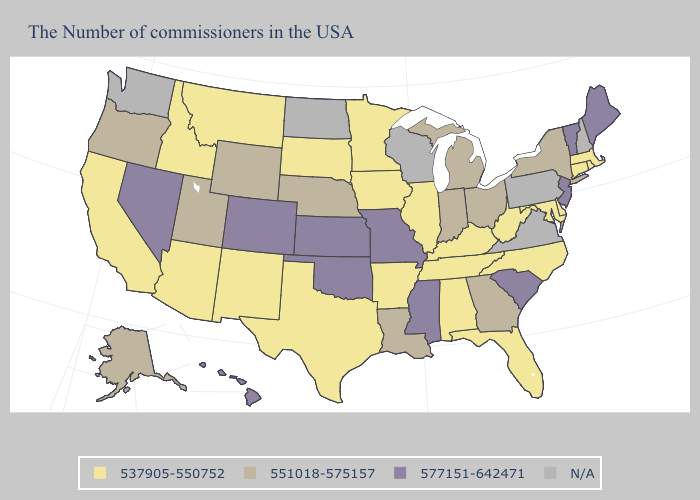What is the value of Arizona?
Concise answer only. 537905-550752. Name the states that have a value in the range 551018-575157?
Concise answer only. New York, Ohio, Georgia, Michigan, Indiana, Louisiana, Nebraska, Wyoming, Utah, Oregon, Alaska. Which states hav the highest value in the Northeast?
Answer briefly. Maine, Vermont, New Jersey. Name the states that have a value in the range 551018-575157?
Answer briefly. New York, Ohio, Georgia, Michigan, Indiana, Louisiana, Nebraska, Wyoming, Utah, Oregon, Alaska. Among the states that border Tennessee , does Arkansas have the lowest value?
Give a very brief answer. Yes. Does Georgia have the highest value in the South?
Give a very brief answer. No. What is the highest value in states that border North Dakota?
Write a very short answer. 537905-550752. Name the states that have a value in the range 577151-642471?
Short answer required. Maine, Vermont, New Jersey, South Carolina, Mississippi, Missouri, Kansas, Oklahoma, Colorado, Nevada, Hawaii. What is the value of Michigan?
Be succinct. 551018-575157. Name the states that have a value in the range N/A?
Short answer required. New Hampshire, Pennsylvania, Virginia, Wisconsin, North Dakota, Washington. What is the highest value in the USA?
Write a very short answer. 577151-642471. What is the highest value in the USA?
Quick response, please. 577151-642471. What is the value of Arkansas?
Give a very brief answer. 537905-550752. 